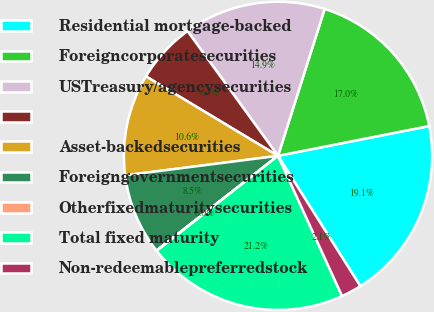Convert chart. <chart><loc_0><loc_0><loc_500><loc_500><pie_chart><fcel>Residential mortgage-backed<fcel>Foreigncorporatesecurities<fcel>USTreasury/agencysecurities<fcel>Unnamed: 3<fcel>Asset-backedsecurities<fcel>Foreigngovernmentsecurities<fcel>Otherfixedmaturitysecurities<fcel>Total fixed maturity<fcel>Non-redeemablepreferredstock<nl><fcel>19.13%<fcel>17.01%<fcel>14.88%<fcel>6.39%<fcel>10.64%<fcel>8.52%<fcel>0.03%<fcel>21.25%<fcel>2.15%<nl></chart> 